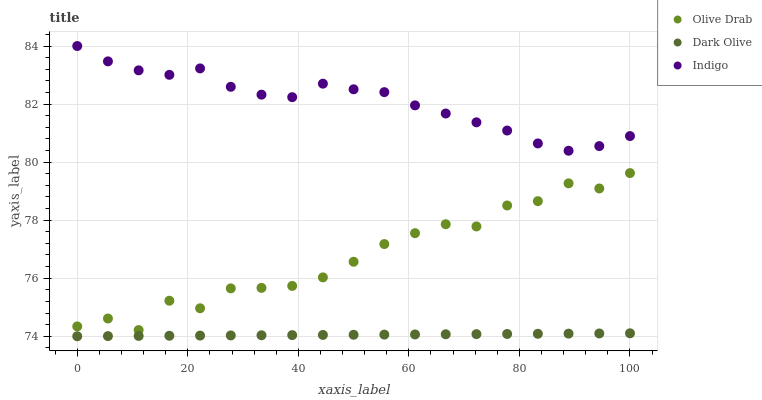Does Dark Olive have the minimum area under the curve?
Answer yes or no. Yes. Does Indigo have the maximum area under the curve?
Answer yes or no. Yes. Does Olive Drab have the minimum area under the curve?
Answer yes or no. No. Does Olive Drab have the maximum area under the curve?
Answer yes or no. No. Is Dark Olive the smoothest?
Answer yes or no. Yes. Is Olive Drab the roughest?
Answer yes or no. Yes. Is Indigo the smoothest?
Answer yes or no. No. Is Indigo the roughest?
Answer yes or no. No. Does Dark Olive have the lowest value?
Answer yes or no. Yes. Does Olive Drab have the lowest value?
Answer yes or no. No. Does Indigo have the highest value?
Answer yes or no. Yes. Does Olive Drab have the highest value?
Answer yes or no. No. Is Dark Olive less than Olive Drab?
Answer yes or no. Yes. Is Indigo greater than Dark Olive?
Answer yes or no. Yes. Does Dark Olive intersect Olive Drab?
Answer yes or no. No. 